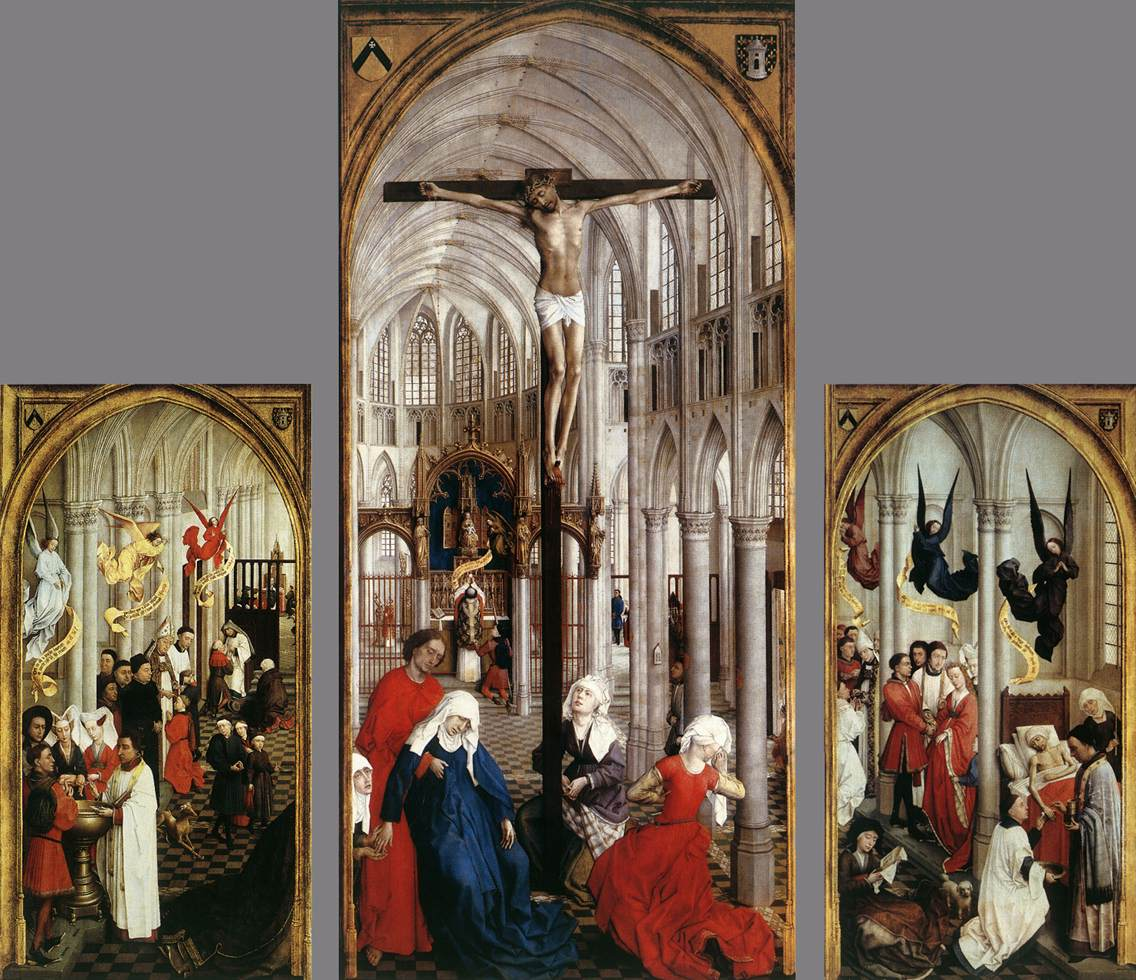Can you elaborate on the elements of the picture provided? The image shows a remarkable triptych painting, a format prevalent in Northern Renaissance art. The central panel dramatically portrays the crucifixion of Jesus Christ inside a meticulously detailed Gothic church, emphasizing the solemnity of the event through architectural grandeur, such as towering arches and ornate stonework.

The left panel depicts an assembly of saints, each characterized by distinct emotional expressions and dressed in vibrantly colored attire, which reflects their spiritual significance and individual stories. This panel quite possibly serves as a narrative on piety and devotion.

On the right, angels are illustrated amidst a celestial backdrop, adding a layer of divine intervention to the human drama. The inclusion of angels highlights the theological concept of redemption and divine presence.

Overall, this triptych not only showcases artistic mastery in its composition and detail but also serves as a rich visual representation of theological themes, reflecting the religious fervor of the period and offering insight into the spiritual and cultural context of the time. 